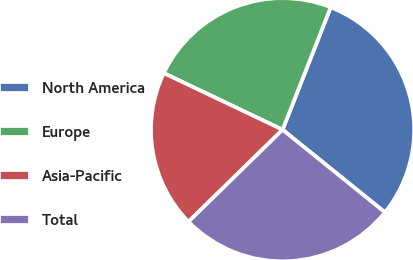Convert chart. <chart><loc_0><loc_0><loc_500><loc_500><pie_chart><fcel>North America<fcel>Europe<fcel>Asia-Pacific<fcel>Total<nl><fcel>29.85%<fcel>23.88%<fcel>19.4%<fcel>26.87%<nl></chart> 